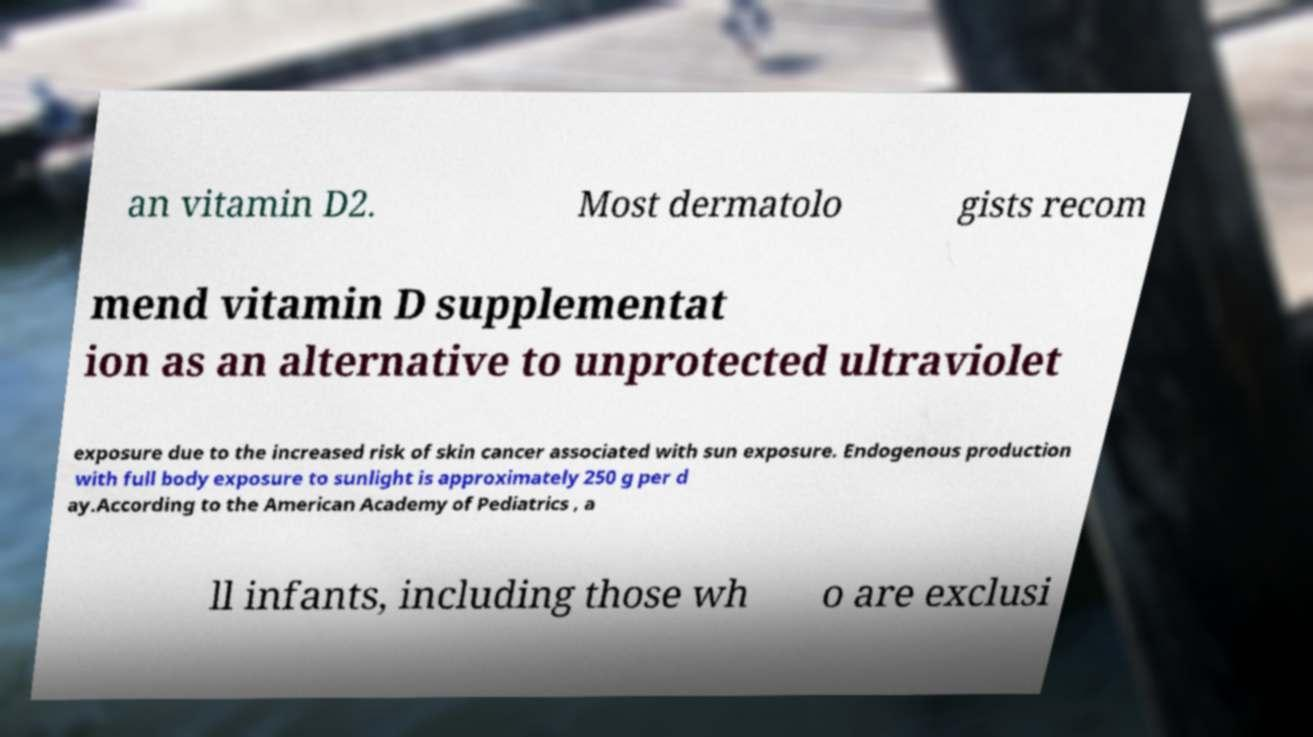There's text embedded in this image that I need extracted. Can you transcribe it verbatim? an vitamin D2. Most dermatolo gists recom mend vitamin D supplementat ion as an alternative to unprotected ultraviolet exposure due to the increased risk of skin cancer associated with sun exposure. Endogenous production with full body exposure to sunlight is approximately 250 g per d ay.According to the American Academy of Pediatrics , a ll infants, including those wh o are exclusi 